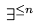<formula> <loc_0><loc_0><loc_500><loc_500>\exists ^ { \leq n }</formula> 